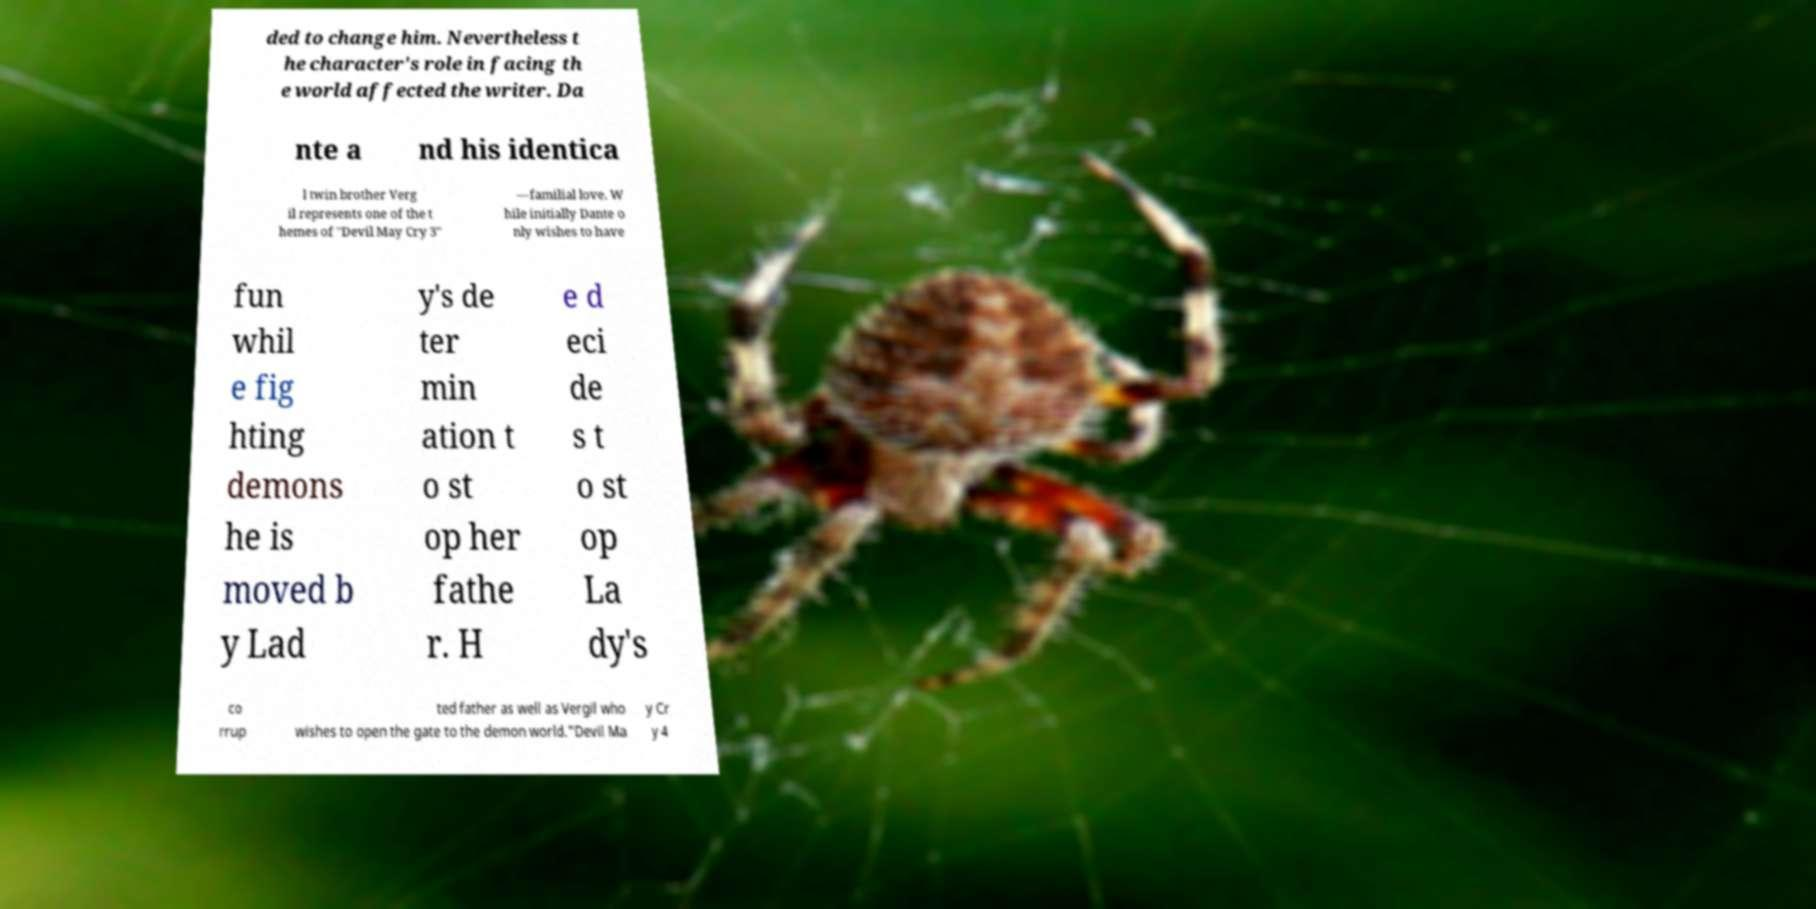Please read and relay the text visible in this image. What does it say? ded to change him. Nevertheless t he character's role in facing th e world affected the writer. Da nte a nd his identica l twin brother Verg il represents one of the t hemes of "Devil May Cry 3" —familial love. W hile initially Dante o nly wishes to have fun whil e fig hting demons he is moved b y Lad y's de ter min ation t o st op her fathe r. H e d eci de s t o st op La dy's co rrup ted father as well as Vergil who wishes to open the gate to the demon world."Devil Ma y Cr y 4 